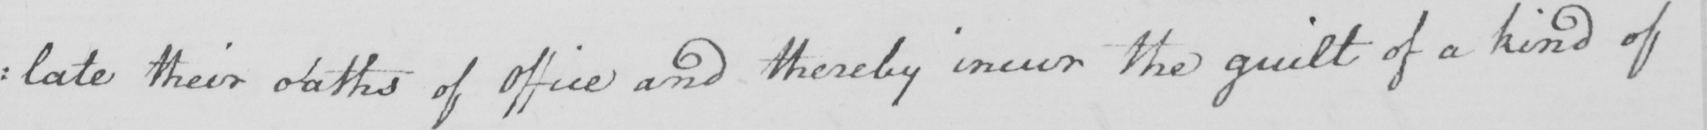Please provide the text content of this handwritten line. : late their oaths of Office and thereby incur the guilt of a kind of 